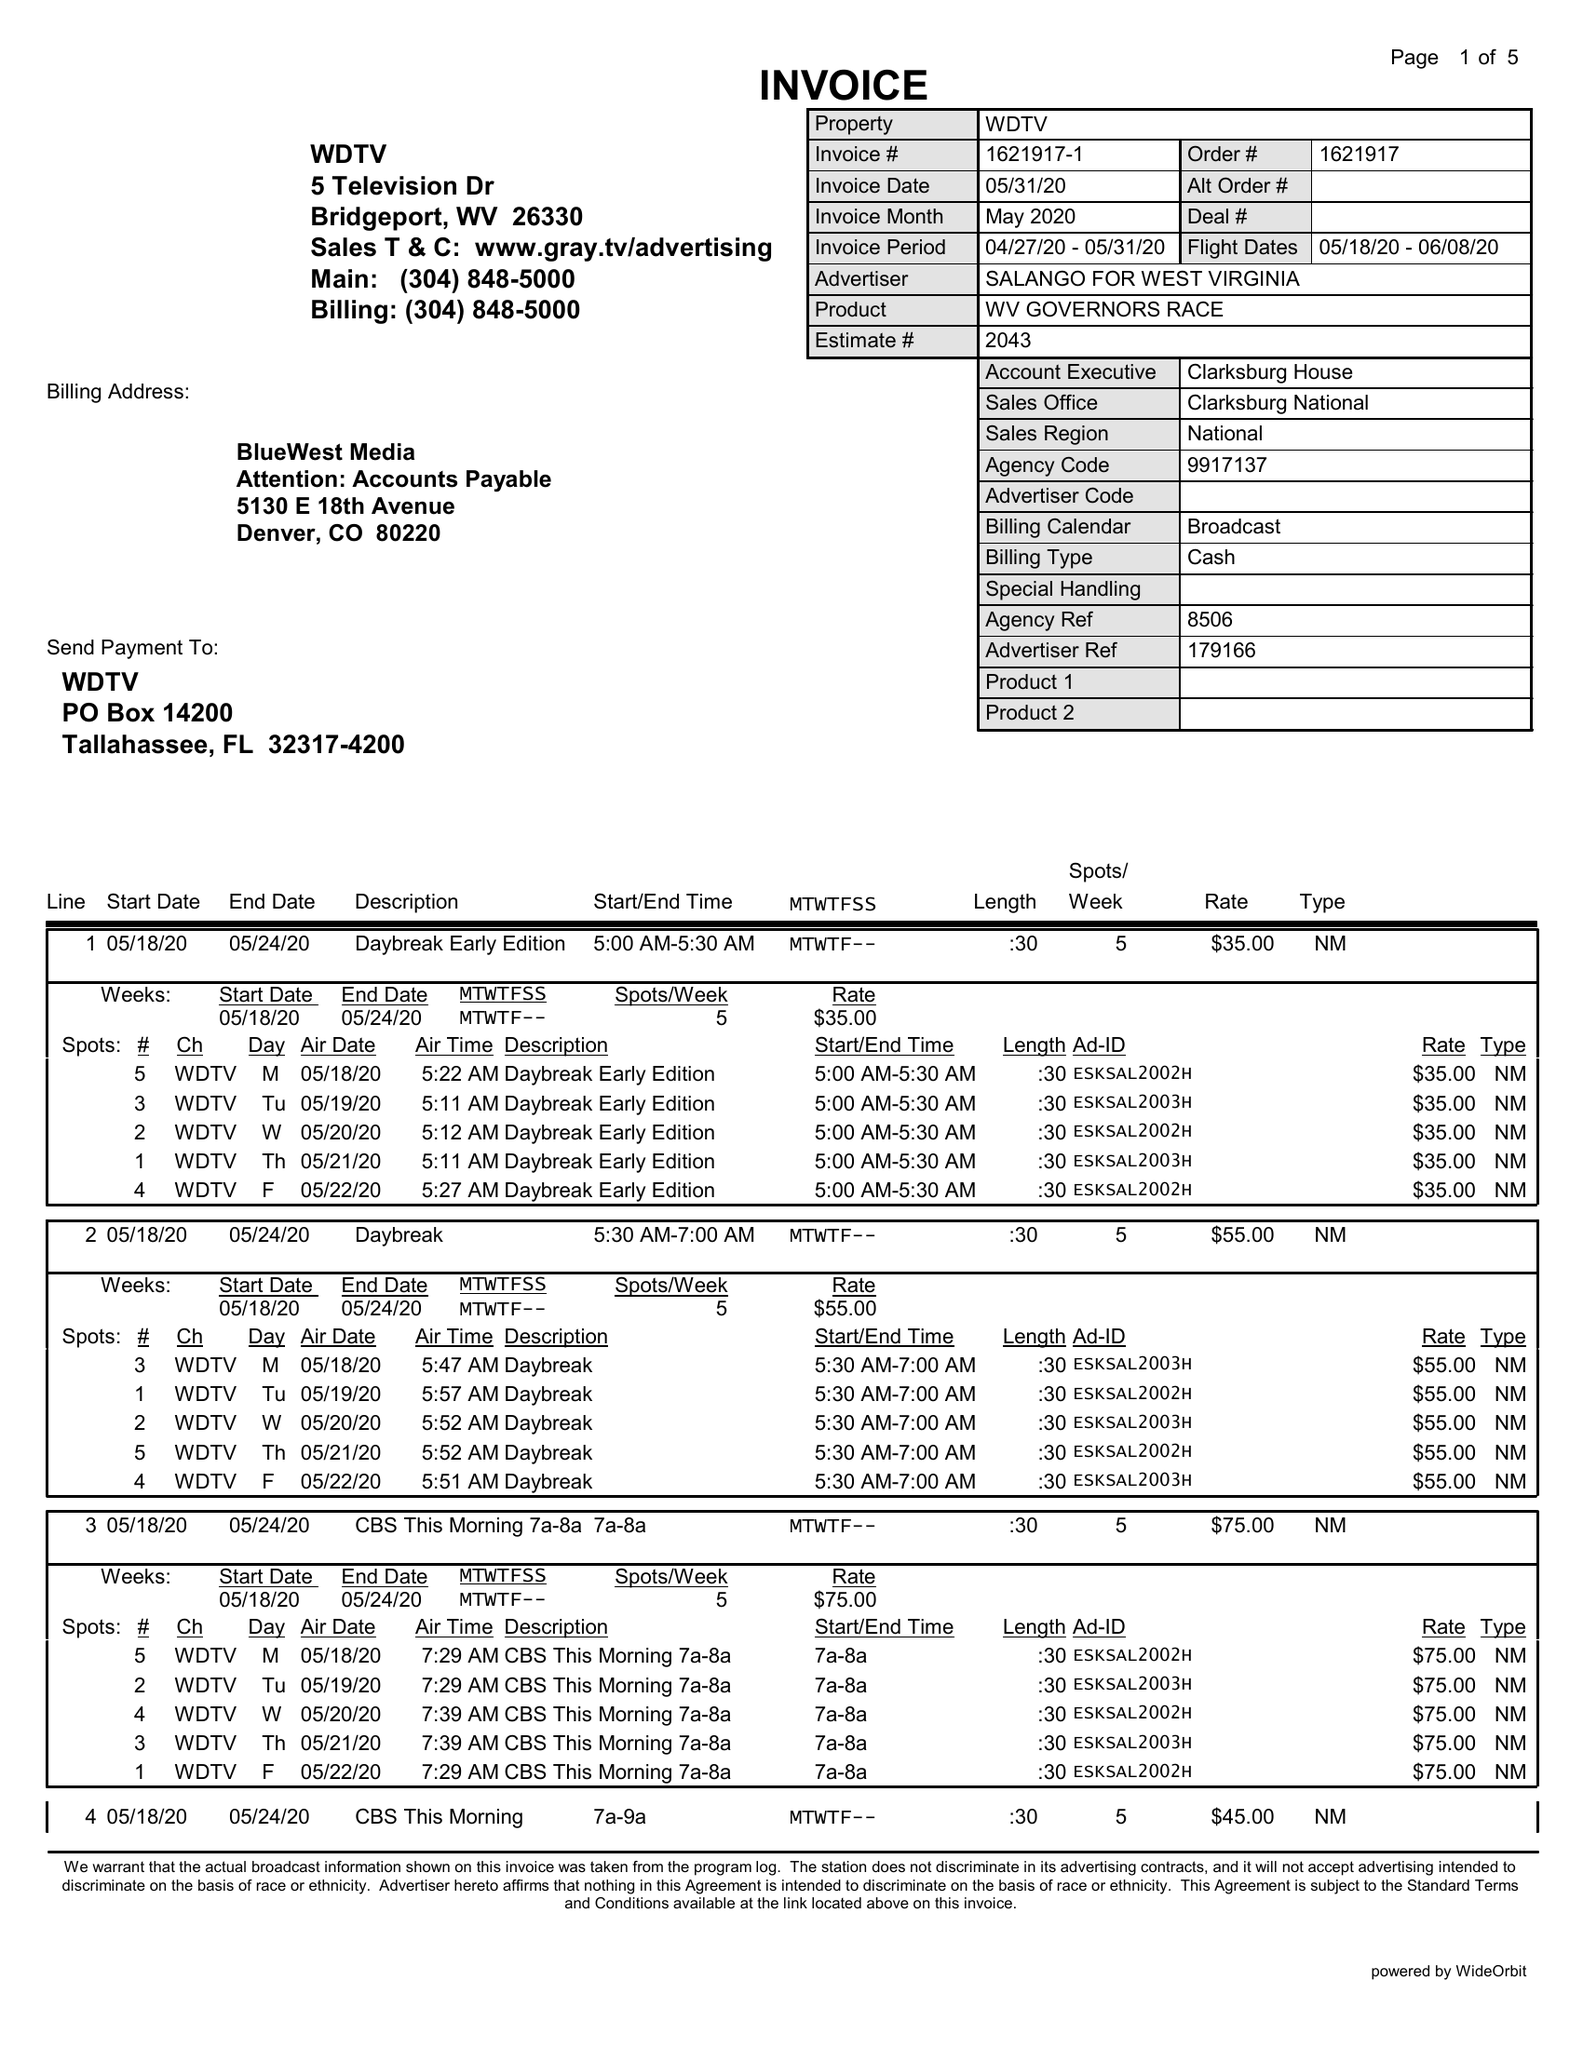What is the value for the flight_from?
Answer the question using a single word or phrase. 05/18/20 